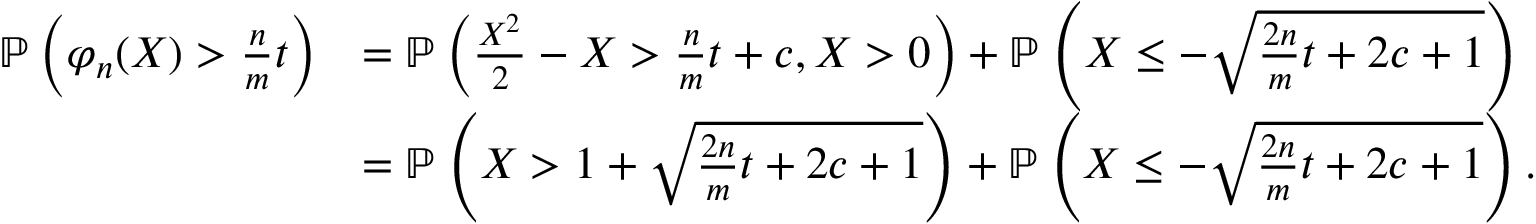<formula> <loc_0><loc_0><loc_500><loc_500>\begin{array} { r l } { \mathbb { P } \left ( { \varphi _ { n } ( X ) > \frac { n } { m } t } \right ) } & { = \mathbb { P } \left ( { \frac { X ^ { 2 } } { 2 } - X > \frac { n } { m } t + c , X > 0 } \right ) + \mathbb { P } \left ( { X \leq - \sqrt { \frac { 2 n } { m } t + 2 c + 1 } } \right ) } \\ & { = \mathbb { P } \left ( { X > 1 + \sqrt { \frac { 2 n } { m } t + 2 c + 1 } } \right ) + \mathbb { P } \left ( { X \leq - \sqrt { \frac { 2 n } { m } t + 2 c + 1 } } \right ) . } \end{array}</formula> 